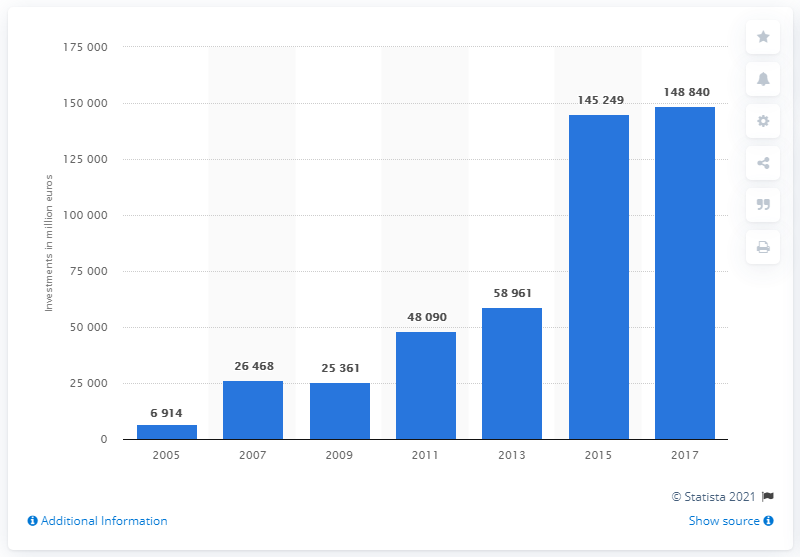List a handful of essential elements in this visual. Investments in companies focused on sustainability on the European market increased significantly from 7 billion euros in 2005 to 148,840 million euros in 2017. 